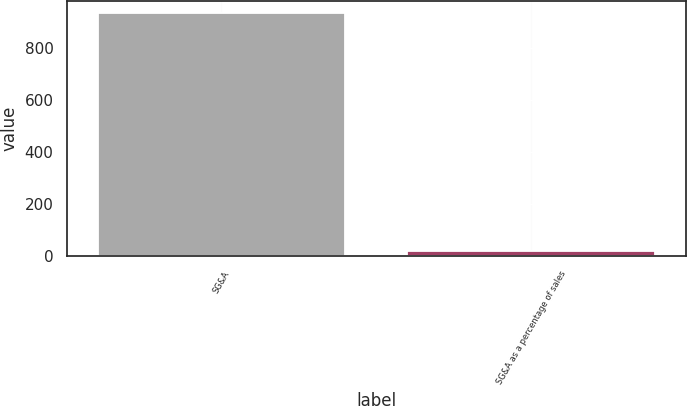<chart> <loc_0><loc_0><loc_500><loc_500><bar_chart><fcel>SG&A<fcel>SG&A as a percentage of sales<nl><fcel>936.9<fcel>19.2<nl></chart> 